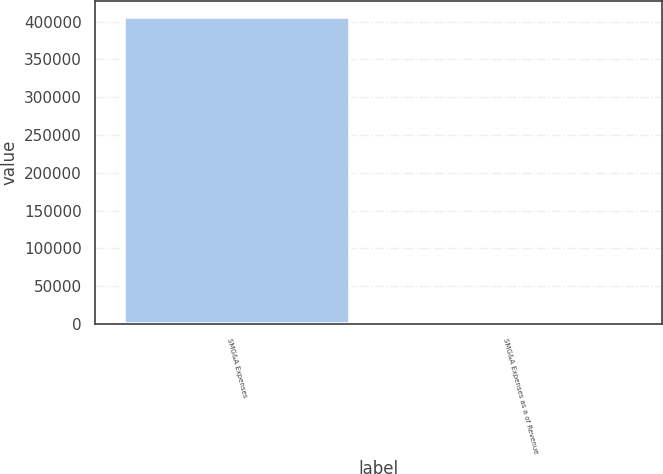<chart> <loc_0><loc_0><loc_500><loc_500><bar_chart><fcel>SMG&A Expenses<fcel>SMG&A Expenses as a of Revenue<nl><fcel>406707<fcel>13.6<nl></chart> 